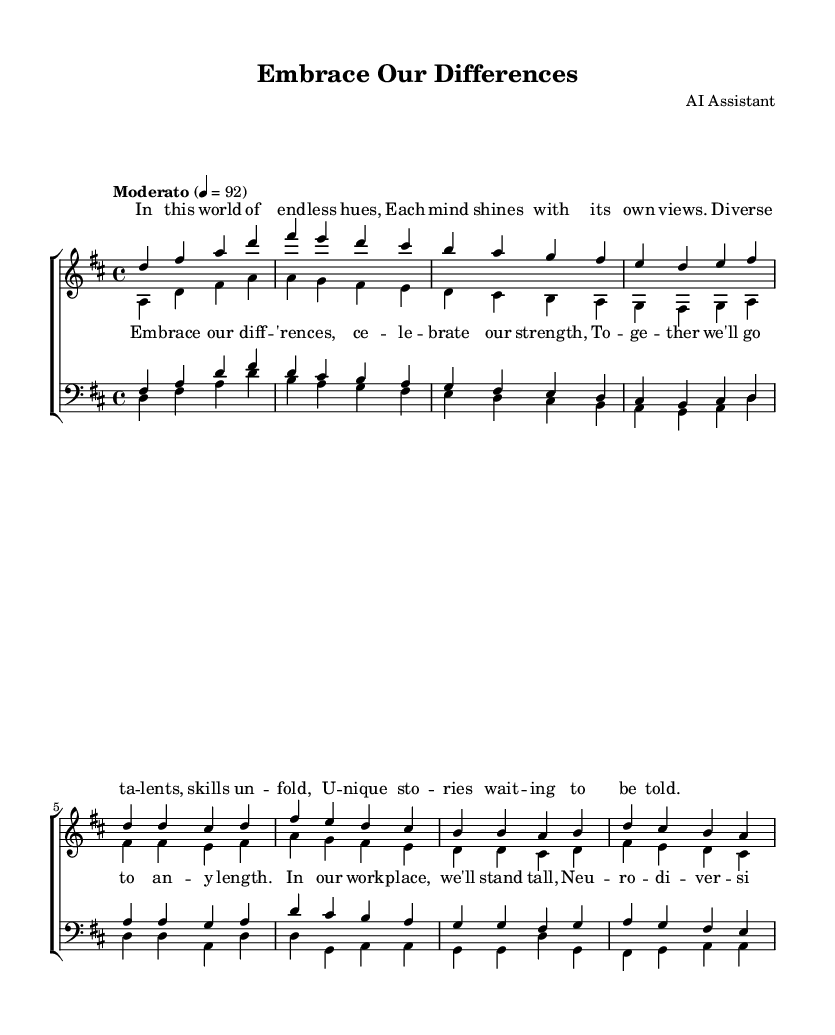What is the key signature of this music? The key signature is indicated by the key signature symbol at the beginning of the staff; here, it shows two sharps, which corresponds to D major or B minor.
Answer: D major What is the time signature of this music? The time signature is shown at the beginning of the staff with the numbers 4 over 4, indicating that each measure has four beats and that a quarter note gets one beat.
Answer: 4/4 What is the tempo marking of this piece? The tempo marking is located at the beginning of the score and specifies "Moderato," indicating a moderate speed of the piece, typically around 92 beats per minute.
Answer: Moderato How many verses are there in the piece? By examining the layout, we can see that there are marked sections labeled as "Verse" for sopranos, altos, tenors, and basses, indicating there are two distinct verses for each voice type.
Answer: 2 What is the primary theme of the lyrics? The lyrics express ideas of embracing differences, celebrating strengths, and promoting neurodiversity and inclusion in the workplace, as highlighted in both the verses and chorus.
Answer: Neurodiversity What are the vocal parts included in this arrangement? The arrangement includes four vocal parts: sopranos, altos, tenors, and basses, as indicated by the labeled staves and voices within the score.
Answer: Sopranos, altos, tenors, and basses How is the chorus structured compared to the verse in terms of voice parts? The chorus features the sopranos and altos singing together, followed by tenors and basses; this structure fosters a blend of voices and enhances the celebratory nature of the lyrics compared to the verses, which are sung individually at first.
Answer: Chorus blends voices 